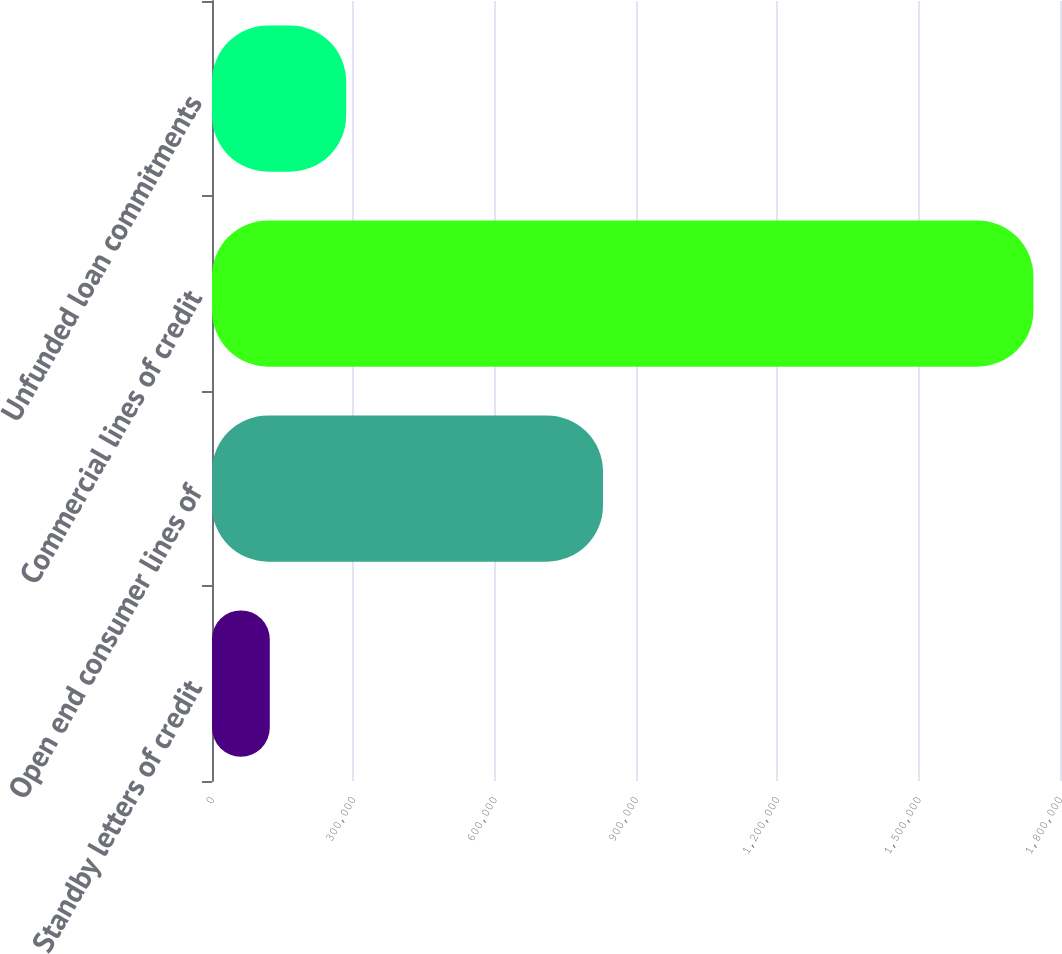Convert chart to OTSL. <chart><loc_0><loc_0><loc_500><loc_500><bar_chart><fcel>Standby letters of credit<fcel>Open end consumer lines of<fcel>Commercial lines of credit<fcel>Unfunded loan commitments<nl><fcel>122672<fcel>829923<fcel>1.74359e+06<fcel>284764<nl></chart> 